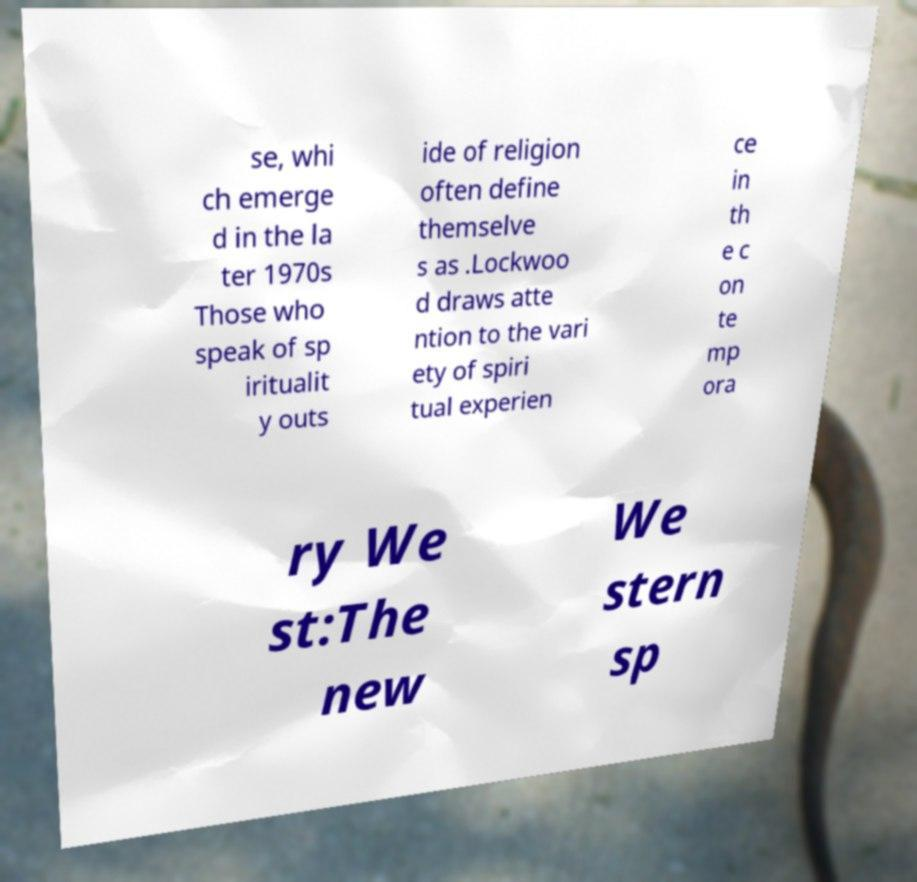For documentation purposes, I need the text within this image transcribed. Could you provide that? se, whi ch emerge d in the la ter 1970s Those who speak of sp iritualit y outs ide of religion often define themselve s as .Lockwoo d draws atte ntion to the vari ety of spiri tual experien ce in th e c on te mp ora ry We st:The new We stern sp 